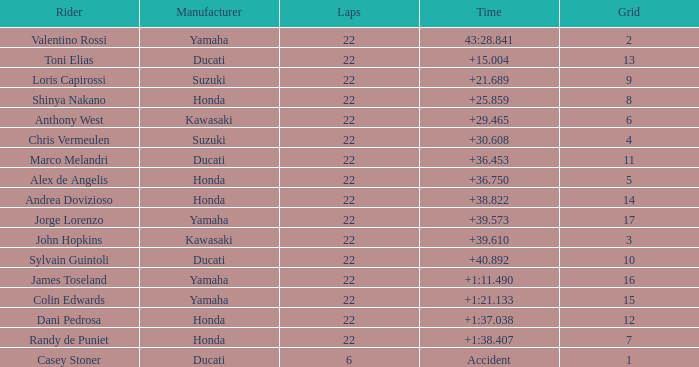What is the highest grid position for honda with a time of 1:38.407 or more? 7.0. 